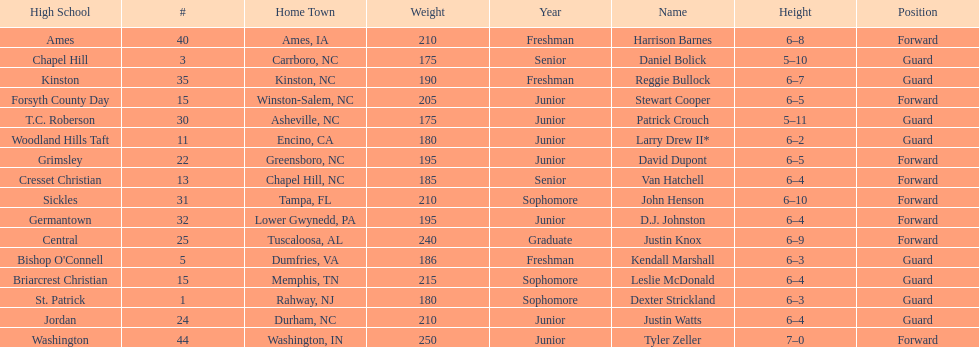Names of players who were exactly 6 feet, 4 inches tall, but did not weight over 200 pounds Van Hatchell, D.J. Johnston. 